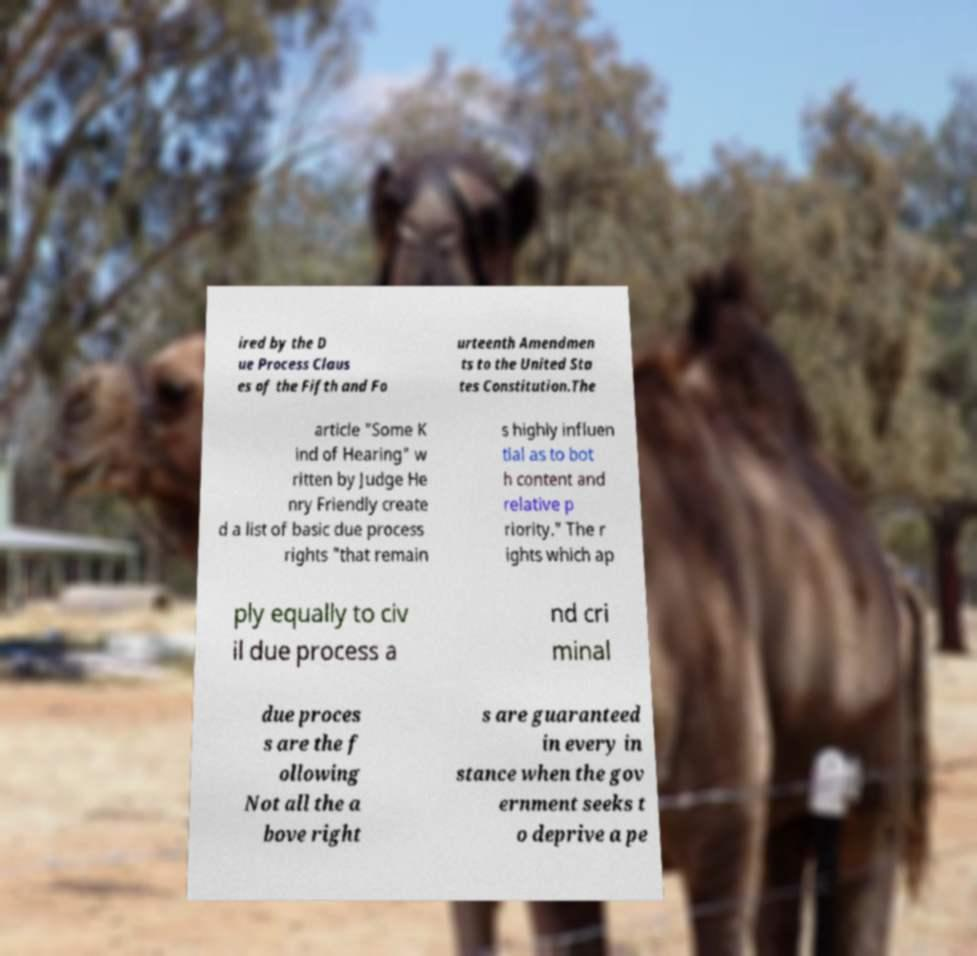Could you assist in decoding the text presented in this image and type it out clearly? ired by the D ue Process Claus es of the Fifth and Fo urteenth Amendmen ts to the United Sta tes Constitution.The article "Some K ind of Hearing" w ritten by Judge He nry Friendly create d a list of basic due process rights "that remain s highly influen tial as to bot h content and relative p riority." The r ights which ap ply equally to civ il due process a nd cri minal due proces s are the f ollowing Not all the a bove right s are guaranteed in every in stance when the gov ernment seeks t o deprive a pe 